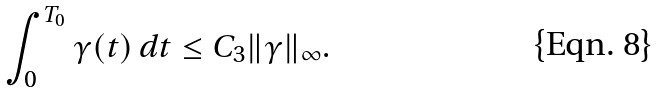<formula> <loc_0><loc_0><loc_500><loc_500>\int _ { 0 } ^ { T _ { 0 } } \gamma ( t ) \, d t \leq C _ { 3 } \| \gamma \| _ { \infty } .</formula> 